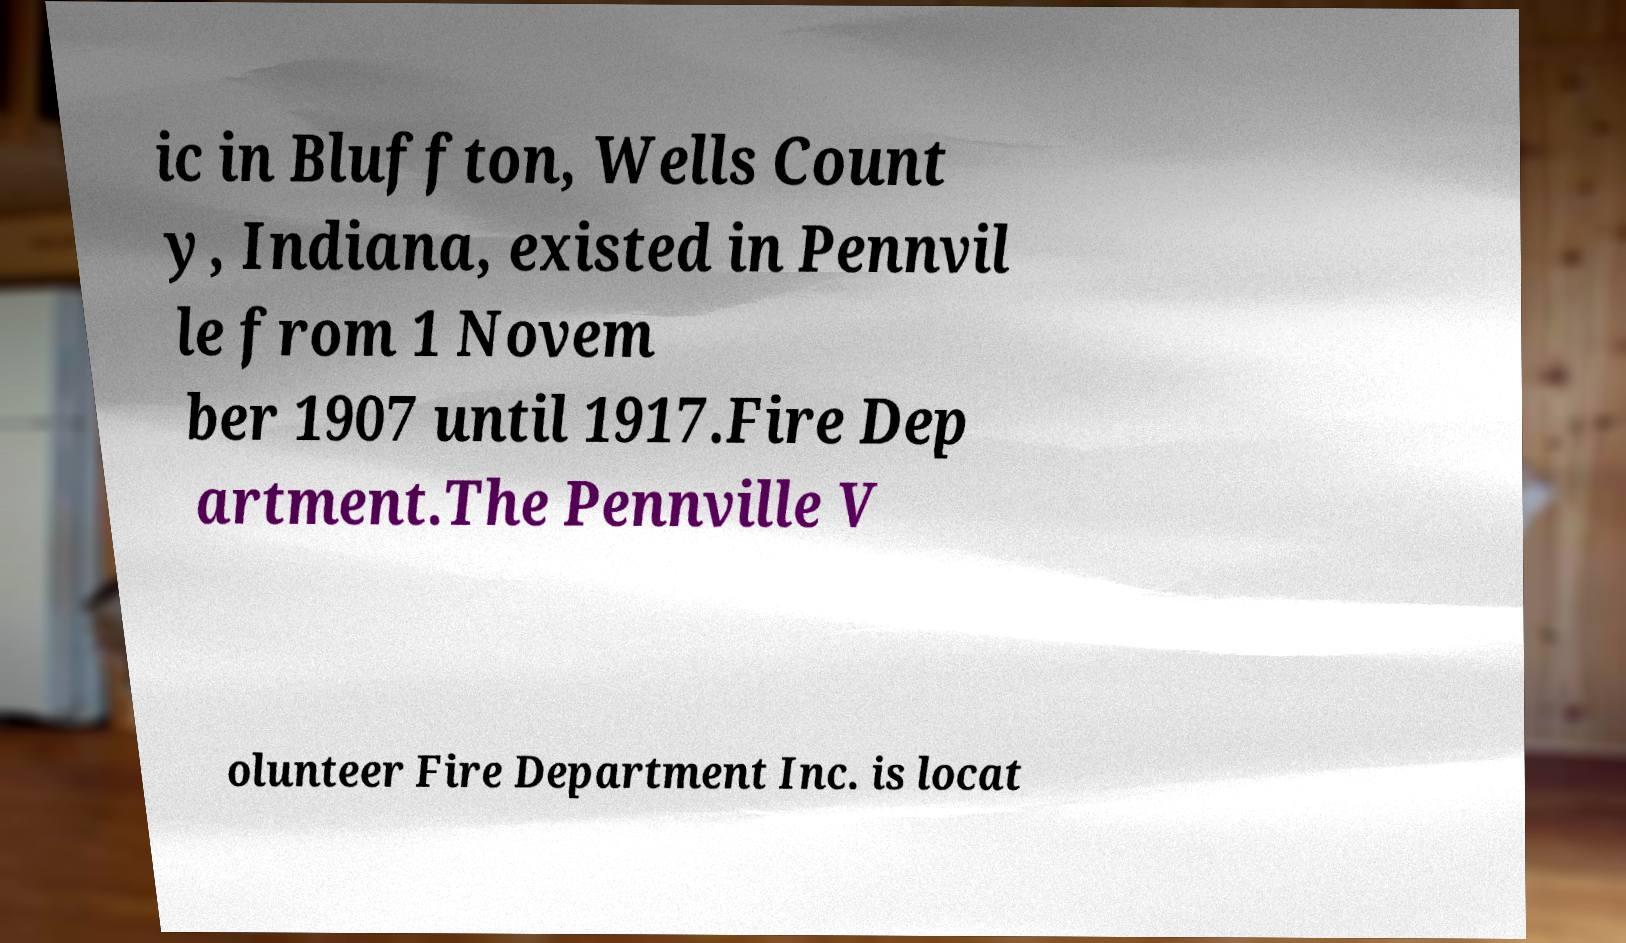Please read and relay the text visible in this image. What does it say? ic in Bluffton, Wells Count y, Indiana, existed in Pennvil le from 1 Novem ber 1907 until 1917.Fire Dep artment.The Pennville V olunteer Fire Department Inc. is locat 